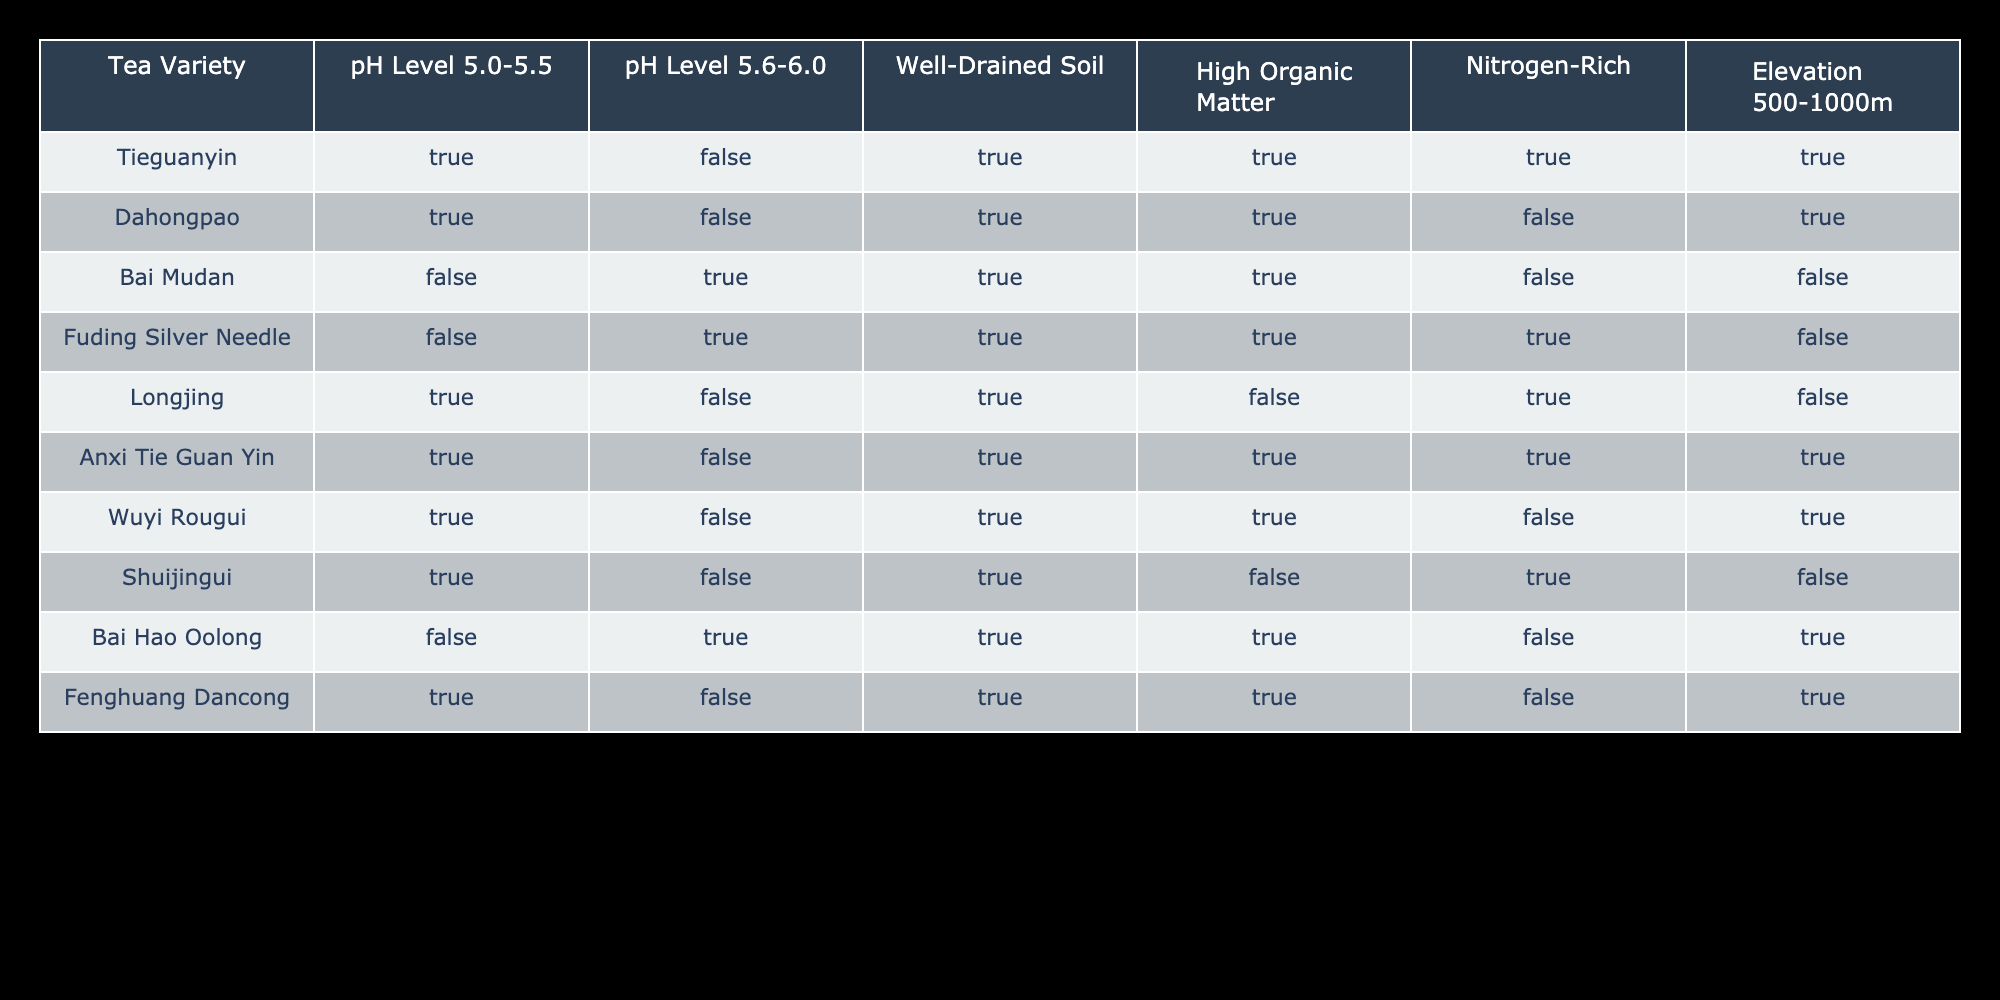What is the pH level required for Tieguanyin? According to the table, Tieguanyin requires a pH level within the range of 5.0-5.5 as indicated by the "TRUE" value in that column.
Answer: 5.0-5.5 Which tea variety prefers high organic matter but not nitrogen-rich soil? Looking at the table, Bai Mudan is unique as it requires high organic matter (TRUE) but does not need nitrogen-rich soil (FALSE).
Answer: Bai Mudan How many tea varieties can grow in well-drained soil? By counting, there are 7 varieties that have "TRUE" in the "Well-Drained Soil" column: Tieguanyin, Dahongpao, Bai Mudan, Fuding Silver Needle, Anxi Tie Guan Yin, Wuyi Rougui, and Fenghuang Dancong. Thus, 7 varieties prefer well-drained soil.
Answer: 7 Are there any tea varieties that require an elevation of 500-1000m? The table shows that Tieguanyin, Dahongpao, Anxi Tie Guan Yin, and Wuyi Rougui all have "TRUE" in the "Elevation 500-1000m" column, indicating they can grow at that elevation.
Answer: Yes What is the average number of tea varieties that require a pH level between 5.0-5.5 and well-drained soil? The tea varieties meeting both criteria are Tieguanyin and Dahongpao. Since there are 2 such varieties, the average is simply the count divided by itself, yielding 2.
Answer: 2 Which tea variety has the highest requirement for nitrogen-rich soil? Analyzing the table, Tieguanyin and Fuding Silver Needle both have "TRUE" for nitrogen-rich soil, but Tieguanyin is the only one with other conditions that are generally favorable as well.
Answer: Tieguanyin What percentage of tea varieties prefer pH levels of 5.6-6.0? The only tea varieties with "TRUE" in the pH Level 5.6-6.0 column are Bai Mudan, Fuding Silver Needle, and Bai Hao Oolong, totaling 3 out of 10 varieties, resulting in a percentage of (3/10)*100 = 30%.
Answer: 30% Is Longjing suitable for high organic matter soil? The table indicates that Longjing has "FALSE" for the high organic matter requirement, meaning it is not suitable for such soil conditions.
Answer: No Which tea variety requires both high organic matter and elevation between 500-1000m? Examining the table, only Tieguanyin requires high organic matter (TRUE) and also the elevation of 500-1000m (TRUE). So, Tieguanyin meets both criteria.
Answer: Tieguanyin 